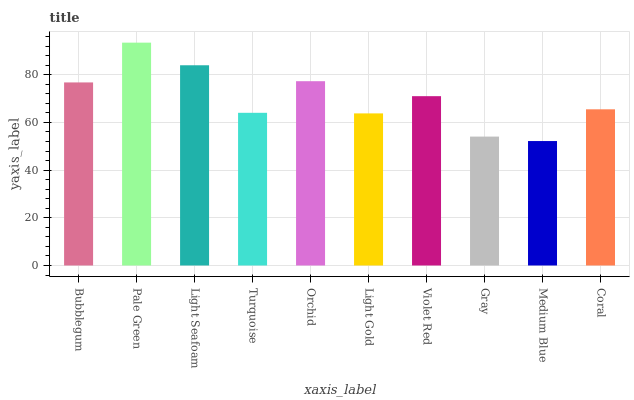Is Light Seafoam the minimum?
Answer yes or no. No. Is Light Seafoam the maximum?
Answer yes or no. No. Is Pale Green greater than Light Seafoam?
Answer yes or no. Yes. Is Light Seafoam less than Pale Green?
Answer yes or no. Yes. Is Light Seafoam greater than Pale Green?
Answer yes or no. No. Is Pale Green less than Light Seafoam?
Answer yes or no. No. Is Violet Red the high median?
Answer yes or no. Yes. Is Coral the low median?
Answer yes or no. Yes. Is Pale Green the high median?
Answer yes or no. No. Is Orchid the low median?
Answer yes or no. No. 